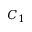Convert formula to latex. <formula><loc_0><loc_0><loc_500><loc_500>C _ { 1 }</formula> 